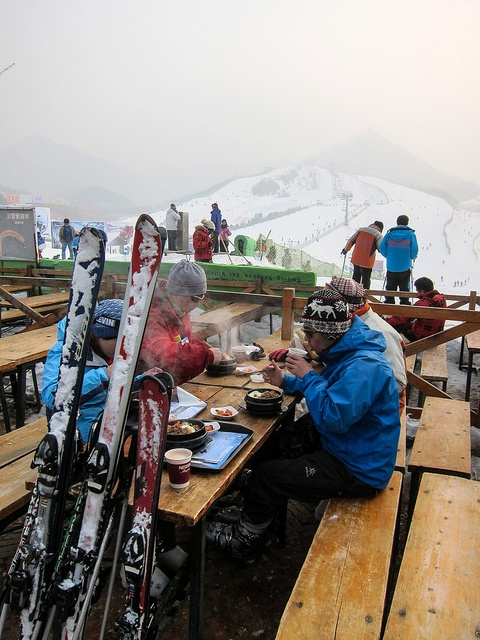Describe the objects in this image and their specific colors. I can see skis in lightgray, black, darkgray, and gray tones, people in lightgray, black, navy, blue, and gray tones, dining table in lightgray, black, gray, and tan tones, bench in lightgray, olive, and tan tones, and bench in lightgray, tan, and gray tones in this image. 